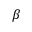Convert formula to latex. <formula><loc_0><loc_0><loc_500><loc_500>\beta</formula> 